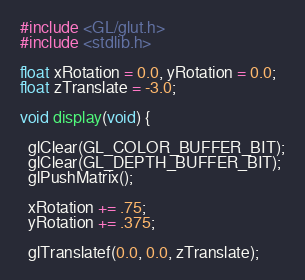Convert code to text. <code><loc_0><loc_0><loc_500><loc_500><_C_>#include <GL/glut.h>
#include <stdlib.h>

float xRotation = 0.0, yRotation = 0.0;
float zTranslate = -3.0;

void display(void) {

  glClear(GL_COLOR_BUFFER_BIT);
  glClear(GL_DEPTH_BUFFER_BIT);
  glPushMatrix();

  xRotation += .75;
  yRotation += .375;

  glTranslatef(0.0, 0.0, zTranslate);</code> 